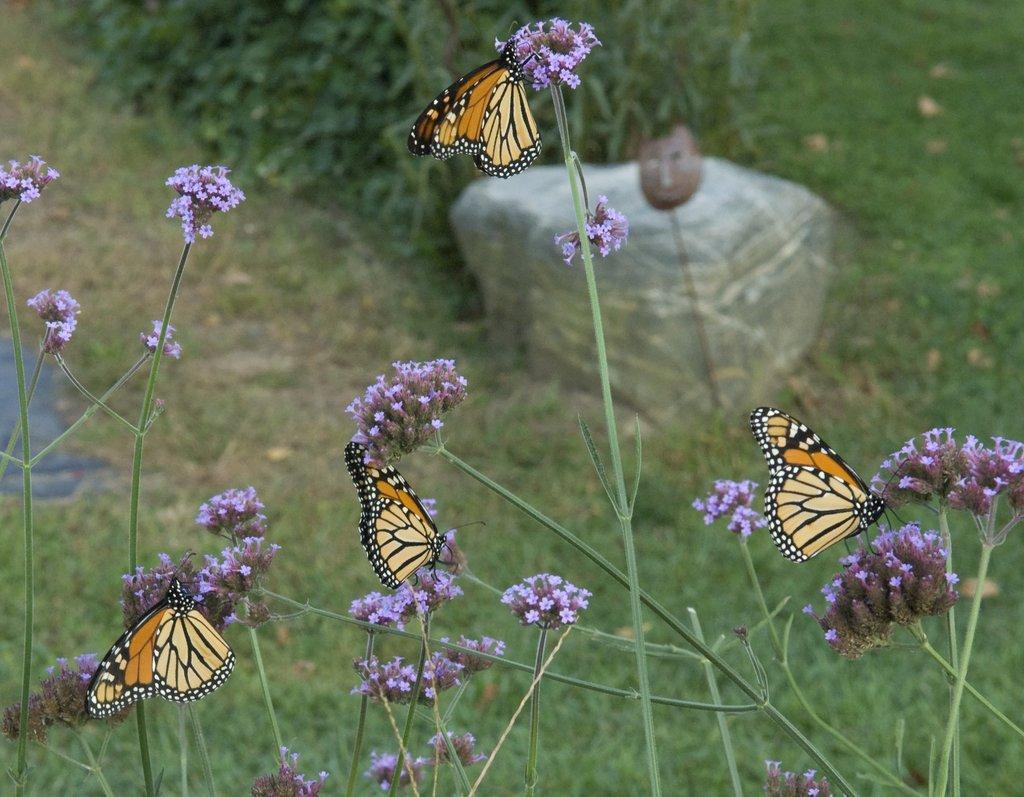Can you describe this image briefly? In the image there is grass with flowers. On the flowers there are butterflies. Behind them on the ground there is grass. And also there is a stone. 